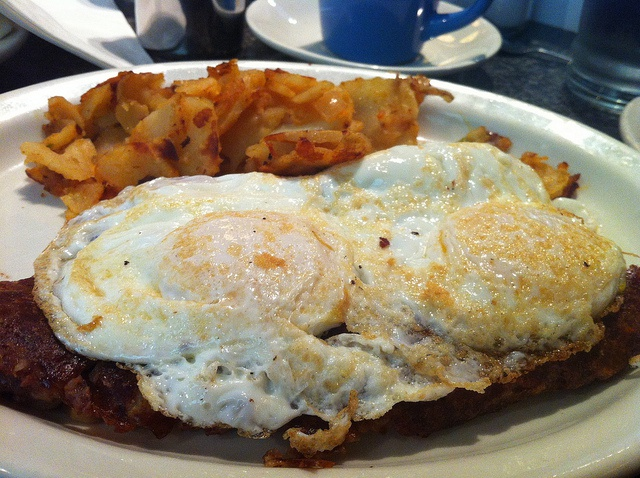Describe the objects in this image and their specific colors. I can see cup in gray, navy, blue, darkblue, and darkgray tones, cup in gray, black, navy, and blue tones, and spoon in gray, black, darkblue, and blue tones in this image. 